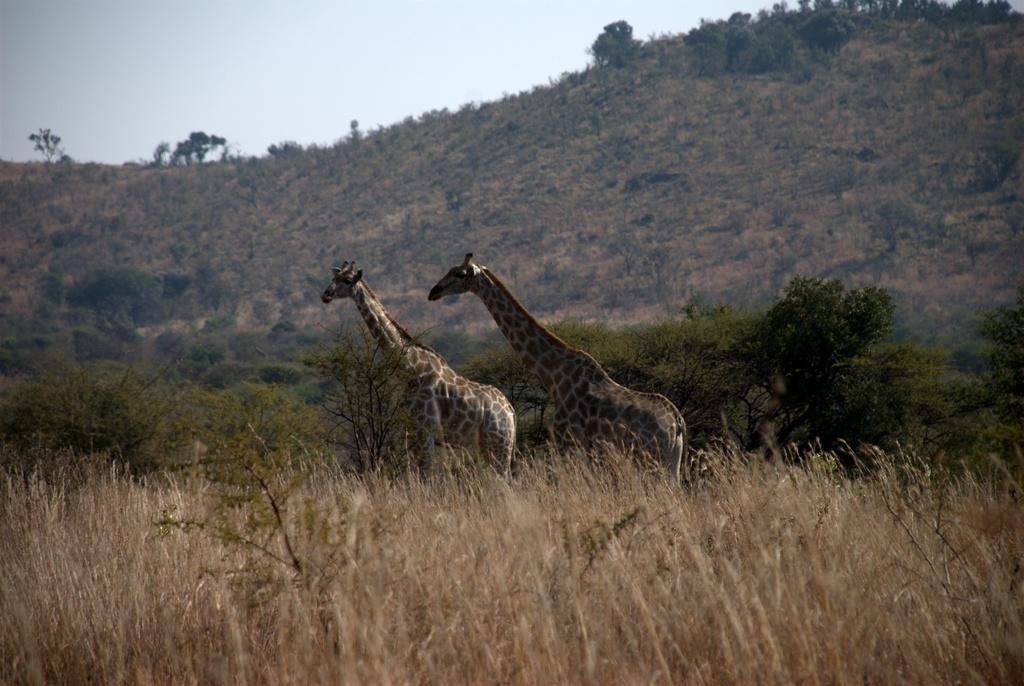How would you summarize this image in a sentence or two? In this image we can see two giraffes and in the background of the image there are some plants, mountain and clear sky. 